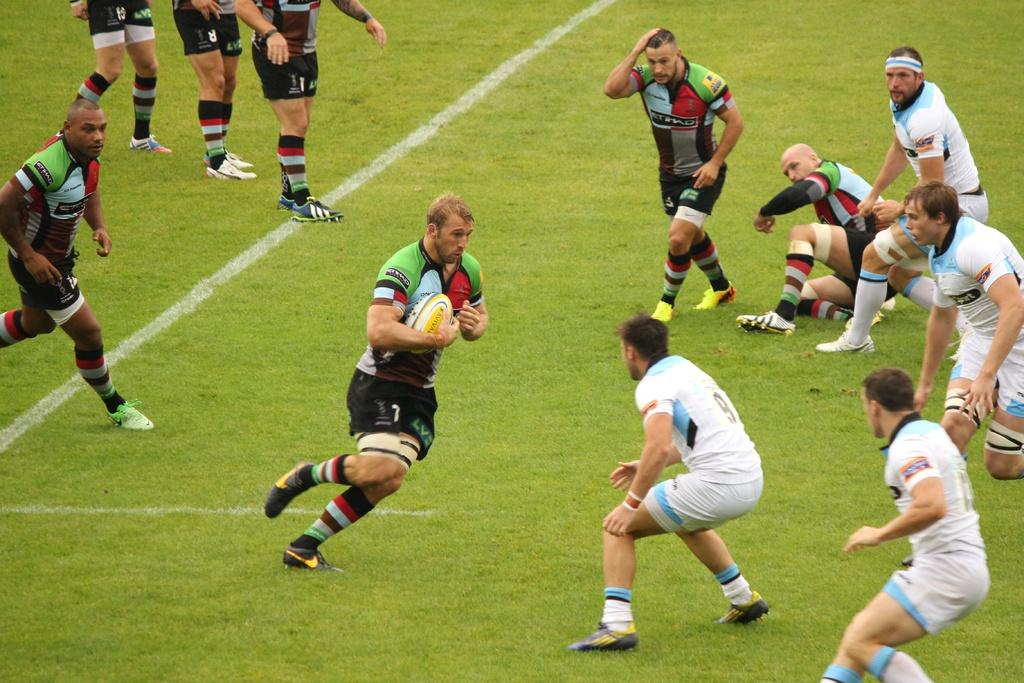Provide a one-sentence caption for the provided image. a player in a rugby match that is running by number 9. 